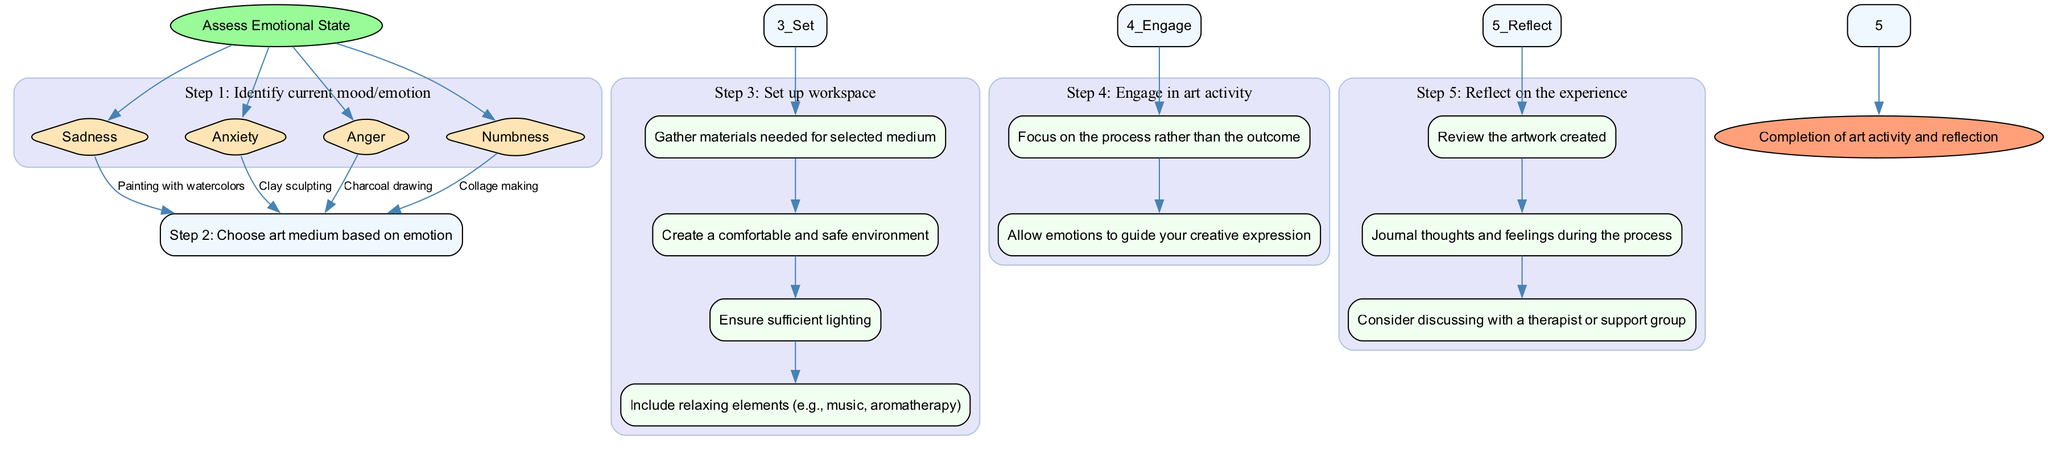What is the first step in the workflow? The diagram starts with the node labeled "Assess Emotional State," which indicates the initiation of the workflow. Therefore, the first step is to assess one's emotional state.
Answer: Assess Emotional State How many options are available in step 1? Step 1 has four options listed under "Identify current mood/emotion," which are Sadness, Anxiety, Anger, and Numbness. This indicates that there are four distinct emotional states to choose from.
Answer: 4 What art medium is suggested for Sadness? According to step 2 of the workflow, if the identified emotional state is Sadness, the suggested art medium is "Painting with watercolors." This is directly stated in the flowchart connecting Sadness to Painting with watercolors.
Answer: Painting with watercolors Which step includes setting up the workspace? The workflow outlines that step 3 is dedicated to "Set up workspace." This step is clearly labeled and encompasses several sub-steps related to workspace preparation.
Answer: Set up workspace In step 5, what is the last action suggested for reflection? The last action in step 5 is "Consider discussing with a therapist or support group." This indicates the concluding thought process related to reflection on the art activity experience.
Answer: Consider discussing with a therapist or support group What is the relationship between emotion and art medium in the flowchart? The flowchart demonstrates a direct linkage between specific emotions (identified in step 1) and their corresponding art mediums (detailed in step 2). For example, Sadness connects to Painting with watercolors.
Answer: Direct linkage How many sub-steps are in step 4? Step 4 contains two sub-steps: "Focus on the process rather than the outcome" and "Allow emotions to guide your creative expression." Thus, the total number of sub-steps in this section is two.
Answer: 2 Which step comes immediately after choosing the art medium? Following the selection of the art medium in step 2, the workflow leads directly to step 3, which involves setting up the workspace. Therefore, step 3 occurs immediately after step 2.
Answer: Step 3 What do the colors in the diagram signify strategically? The diagram uses different colors to categorize the steps and differentiate between main steps, sub-steps, start, and end points. For instance, green indicates the start and orange represents the end, enhancing visual clarity and flow.
Answer: Categorization and clarity 